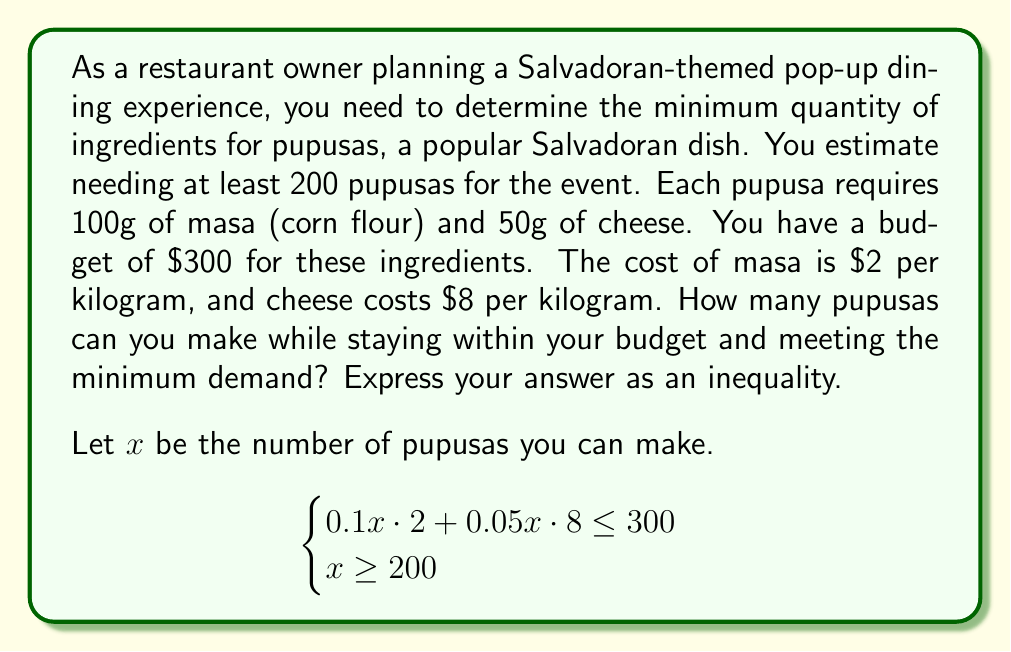Could you help me with this problem? Let's approach this problem step by step:

1) First, let's set up the inequality for the budget constraint:
   - Cost of masa per pupusa: $0.1 \text{ kg} \cdot \$2/\text{kg} = \$0.2$
   - Cost of cheese per pupusa: $0.05 \text{ kg} \cdot \$8/\text{kg} = \$0.4$
   - Total cost per pupusa: $\$0.2 + \$0.4 = \$0.6$
   - Budget constraint: $0.6x \leq 300$

2) Simplify the budget constraint:
   $$0.6x \leq 300$$
   $$x \leq 500$$

3) We also have the minimum demand constraint:
   $$x \geq 200$$

4) Combining these inequalities:
   $$200 \leq x \leq 500$$

5) Therefore, the number of pupusas ($x$) that can be made while staying within budget and meeting minimum demand is represented by this compound inequality.
Answer: $200 \leq x \leq 500$, where $x$ is the number of pupusas. 